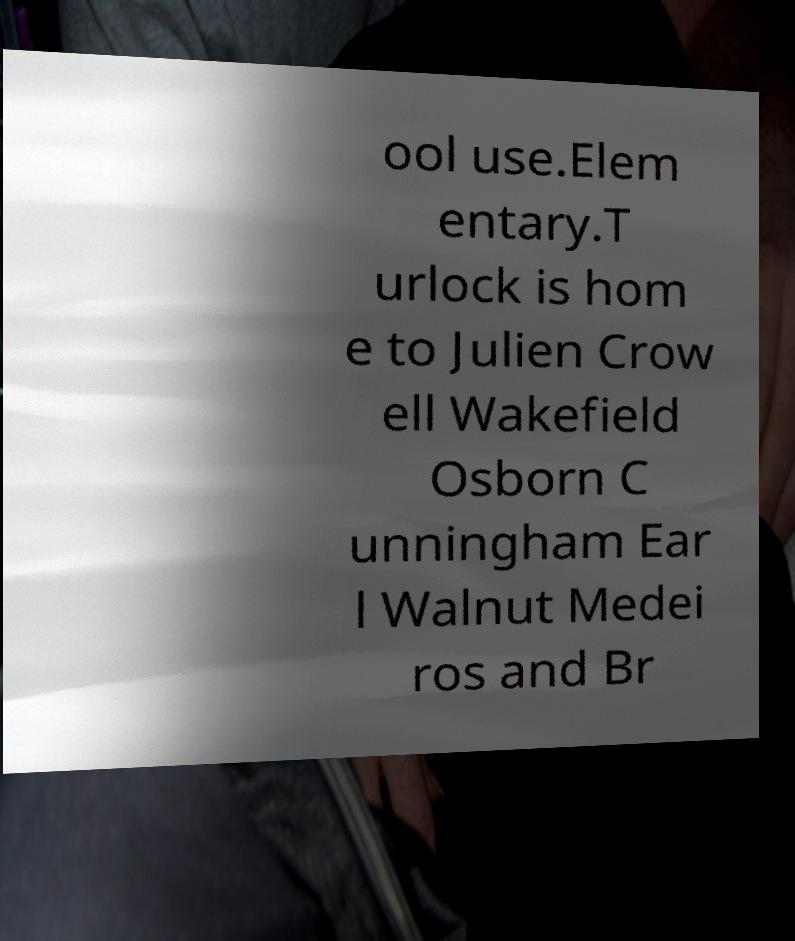I need the written content from this picture converted into text. Can you do that? ool use.Elem entary.T urlock is hom e to Julien Crow ell Wakefield Osborn C unningham Ear l Walnut Medei ros and Br 